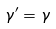<formula> <loc_0><loc_0><loc_500><loc_500>\gamma ^ { \prime } = \gamma</formula> 